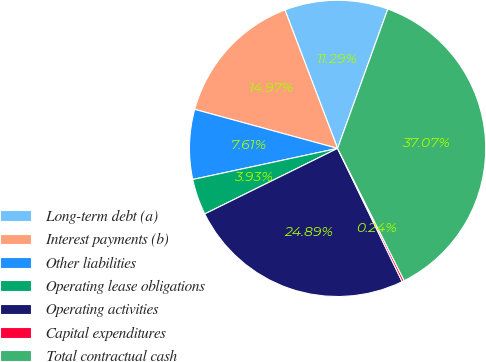Convert chart to OTSL. <chart><loc_0><loc_0><loc_500><loc_500><pie_chart><fcel>Long-term debt (a)<fcel>Interest payments (b)<fcel>Other liabilities<fcel>Operating lease obligations<fcel>Operating activities<fcel>Capital expenditures<fcel>Total contractual cash<nl><fcel>11.29%<fcel>14.97%<fcel>7.61%<fcel>3.93%<fcel>24.89%<fcel>0.24%<fcel>37.07%<nl></chart> 